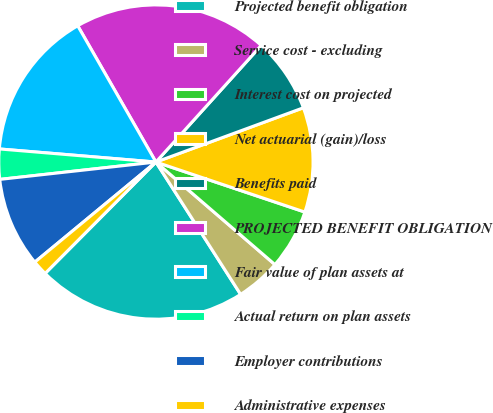<chart> <loc_0><loc_0><loc_500><loc_500><pie_chart><fcel>Projected benefit obligation<fcel>Service cost - excluding<fcel>Interest cost on projected<fcel>Net actuarial (gain)/loss<fcel>Benefits paid<fcel>PROJECTED BENEFIT OBLIGATION<fcel>Fair value of plan assets at<fcel>Actual return on plan assets<fcel>Employer contributions<fcel>Administrative expenses<nl><fcel>21.52%<fcel>4.62%<fcel>6.16%<fcel>10.77%<fcel>7.7%<fcel>19.98%<fcel>15.38%<fcel>3.09%<fcel>9.23%<fcel>1.55%<nl></chart> 